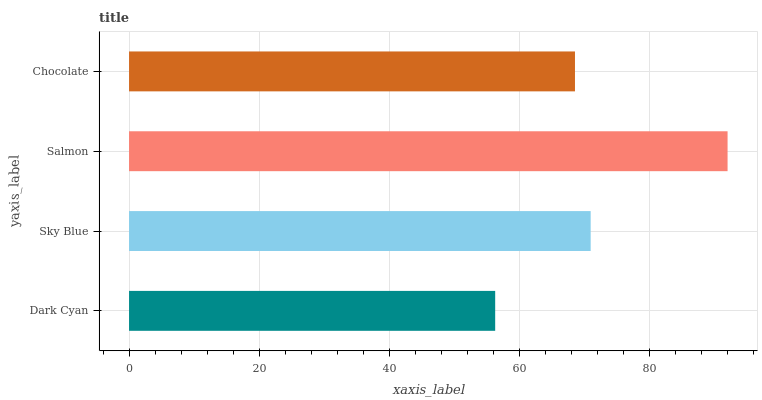Is Dark Cyan the minimum?
Answer yes or no. Yes. Is Salmon the maximum?
Answer yes or no. Yes. Is Sky Blue the minimum?
Answer yes or no. No. Is Sky Blue the maximum?
Answer yes or no. No. Is Sky Blue greater than Dark Cyan?
Answer yes or no. Yes. Is Dark Cyan less than Sky Blue?
Answer yes or no. Yes. Is Dark Cyan greater than Sky Blue?
Answer yes or no. No. Is Sky Blue less than Dark Cyan?
Answer yes or no. No. Is Sky Blue the high median?
Answer yes or no. Yes. Is Chocolate the low median?
Answer yes or no. Yes. Is Salmon the high median?
Answer yes or no. No. Is Sky Blue the low median?
Answer yes or no. No. 